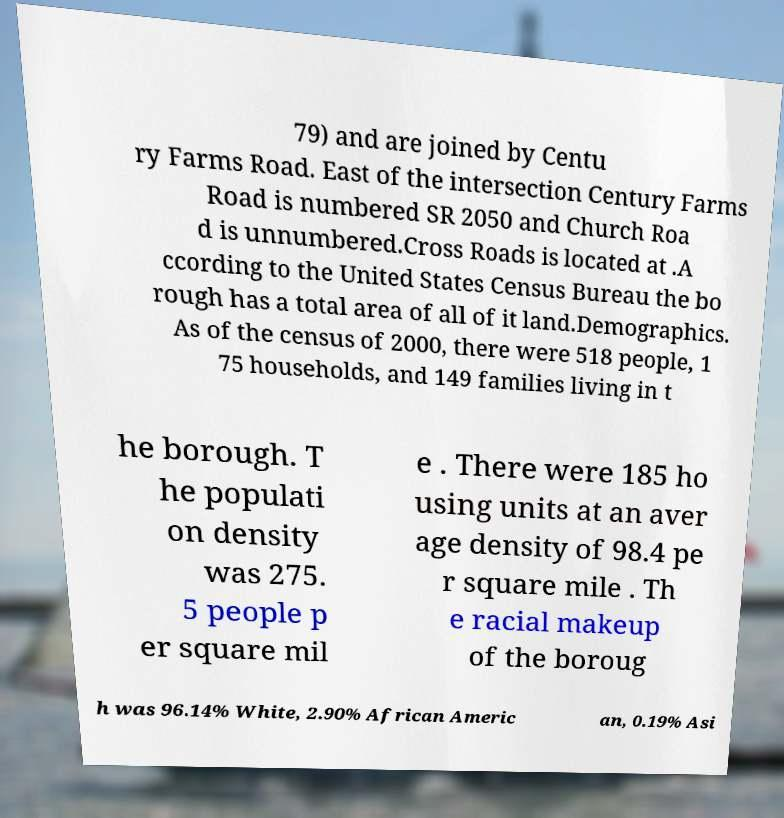Can you accurately transcribe the text from the provided image for me? 79) and are joined by Centu ry Farms Road. East of the intersection Century Farms Road is numbered SR 2050 and Church Roa d is unnumbered.Cross Roads is located at .A ccording to the United States Census Bureau the bo rough has a total area of all of it land.Demographics. As of the census of 2000, there were 518 people, 1 75 households, and 149 families living in t he borough. T he populati on density was 275. 5 people p er square mil e . There were 185 ho using units at an aver age density of 98.4 pe r square mile . Th e racial makeup of the boroug h was 96.14% White, 2.90% African Americ an, 0.19% Asi 